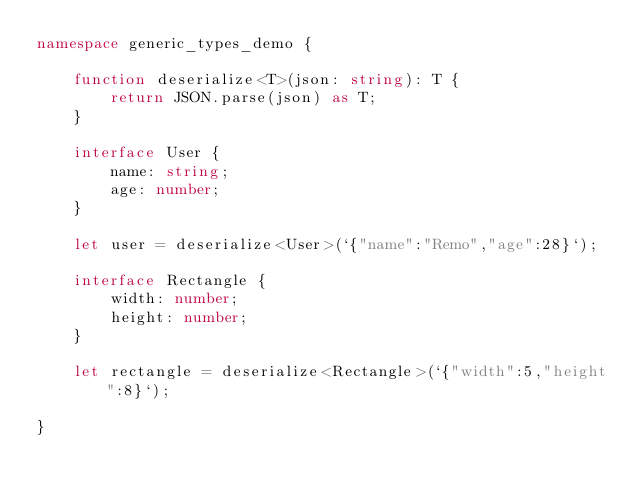Convert code to text. <code><loc_0><loc_0><loc_500><loc_500><_TypeScript_>namespace generic_types_demo {

    function deserialize<T>(json: string): T {
        return JSON.parse(json) as T;
    }

    interface User {
        name: string;
        age: number;
    }

    let user = deserialize<User>(`{"name":"Remo","age":28}`);

    interface Rectangle {
        width: number;
        height: number;
    }

    let rectangle = deserialize<Rectangle>(`{"width":5,"height":8}`);

}
</code> 